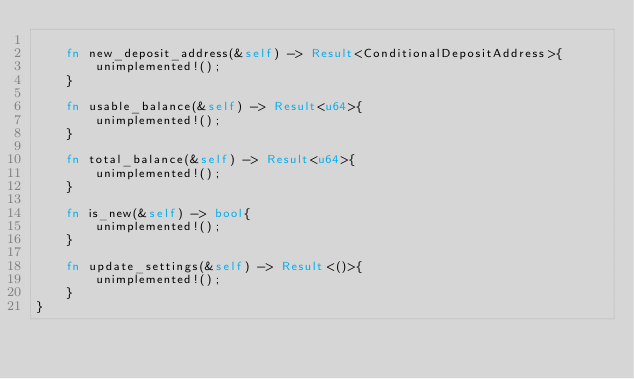Convert code to text. <code><loc_0><loc_0><loc_500><loc_500><_Rust_>
    fn new_deposit_address(&self) -> Result<ConditionalDepositAddress>{
        unimplemented!();
    }

    fn usable_balance(&self) -> Result<u64>{
        unimplemented!();
    }

    fn total_balance(&self) -> Result<u64>{
        unimplemented!();
    }

    fn is_new(&self) -> bool{
        unimplemented!();
    }

    fn update_settings(&self) -> Result<()>{
        unimplemented!();
    }
}</code> 